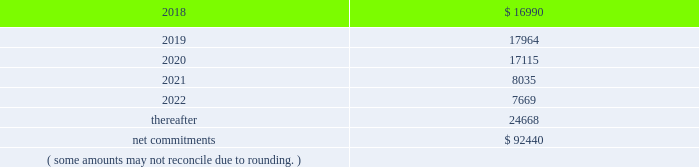On november 18 , 2014 , the company entered into a collateralized reinsurance agreement with kilimanjaro to provide the company with catastrophe reinsurance coverage .
This agreement is a multi-year reinsurance contract which covers specified earthquake events .
The agreement provides up to $ 500000 thousand of reinsurance coverage from earthquakes in the united states , puerto rico and canada .
On december 1 , 2015 the company entered into two collateralized reinsurance agreements with kilimanjaro re to provide the company with catastrophe reinsurance coverage .
These agreements are multi-year reinsurance contracts which cover named storm and earthquake events .
The first agreement provides up to $ 300000 thousand of reinsurance coverage from named storms and earthquakes in the united states , puerto rico and canada .
The second agreement provides up to $ 325000 thousand of reinsurance coverage from named storms and earthquakes in the united states , puerto rico and canada .
On april 13 , 2017 the company entered into six collateralized reinsurance agreements with kilimanjaro to provide the company with annual aggregate catastrophe reinsurance coverage .
The initial three agreements are four year reinsurance contracts which cover named storm and earthquake events .
These agreements provide up to $ 225000 thousand , $ 400000 thousand and $ 325000 thousand , respectively , of annual aggregate reinsurance coverage from named storms and earthquakes in the united states , puerto rico and canada .
The subsequent three agreements are five year reinsurance contracts which cover named storm and earthquake events .
These agreements provide up to $ 50000 thousand , $ 75000 thousand and $ 175000 thousand , respectively , of annual aggregate reinsurance coverage from named storms and earthquakes in the united states , puerto rico and canada .
Recoveries under these collateralized reinsurance agreements with kilimanjaro are primarily dependent on estimated industry level insured losses from covered events , as well as , the geographic location of the events .
The estimated industry level of insured losses is obtained from published estimates by an independent recognized authority on insured property losses .
As of december 31 , 2017 , none of the published insured loss estimates for the 2017 catastrophe events have exceeded the single event retentions under the terms of the agreements that would result in a recovery .
In addition , the aggregation of the to-date published insured loss estimates for the 2017 covered events have not exceeded the aggregated retentions for recovery .
However , if the published estimates for insured losses for the covered 2017 events increase , the aggregate losses may exceed the aggregate event retentions under the agreements , resulting in a recovery .
Kilimanjaro has financed the various property catastrophe reinsurance coverages by issuing catastrophe bonds to unrelated , external investors .
On april 24 , 2014 , kilimanjaro issued $ 450000 thousand of notes ( 201cseries 2014-1 notes 201d ) .
On november 18 , 2014 , kilimanjaro issued $ 500000 thousand of notes ( 201cseries 2014-2 notes 201d ) .
On december 1 , 2015 , kilimanjaro issued $ 625000 thousand of notes ( 201cseries 2015-1 notes ) .
On april 13 , 2017 , kilimanjaro issued $ 950000 thousand of notes ( 201cseries 2017-1 notes ) and $ 300000 thousand of notes ( 201cseries 2017-2 notes ) .
The proceeds from the issuance of the notes listed above are held in reinsurance trust throughout the duration of the applicable reinsurance agreements and invested solely in us government money market funds with a rating of at least 201caaam 201d by standard & poor 2019s .
Operating lease agreements the future minimum rental commitments , exclusive of cost escalation clauses , at december 31 , 2017 , for all of the company 2019s operating leases with remaining non-cancelable terms in excess of one year are as follows : ( dollars in thousands ) .

What portion of the minimum future commitments is due in the next 12 months? 
Computations: (16990 / 92440)
Answer: 0.18379. 